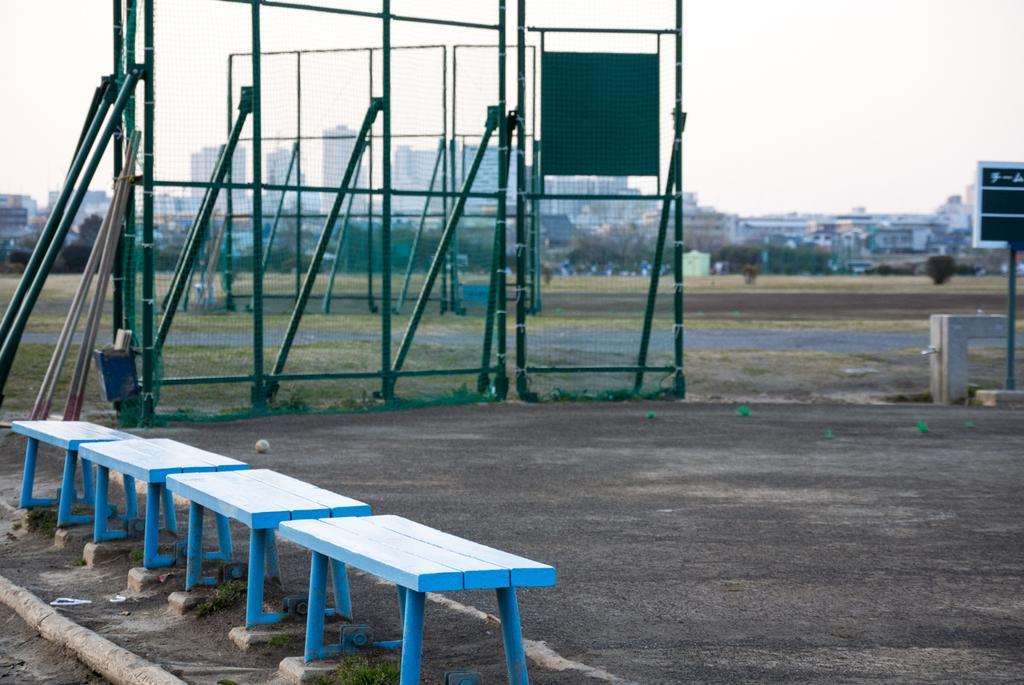Could you give a brief overview of what you see in this image? There are few blue colored tables in the left corner and there is a green color fence beside it and there are buildings in the background. 